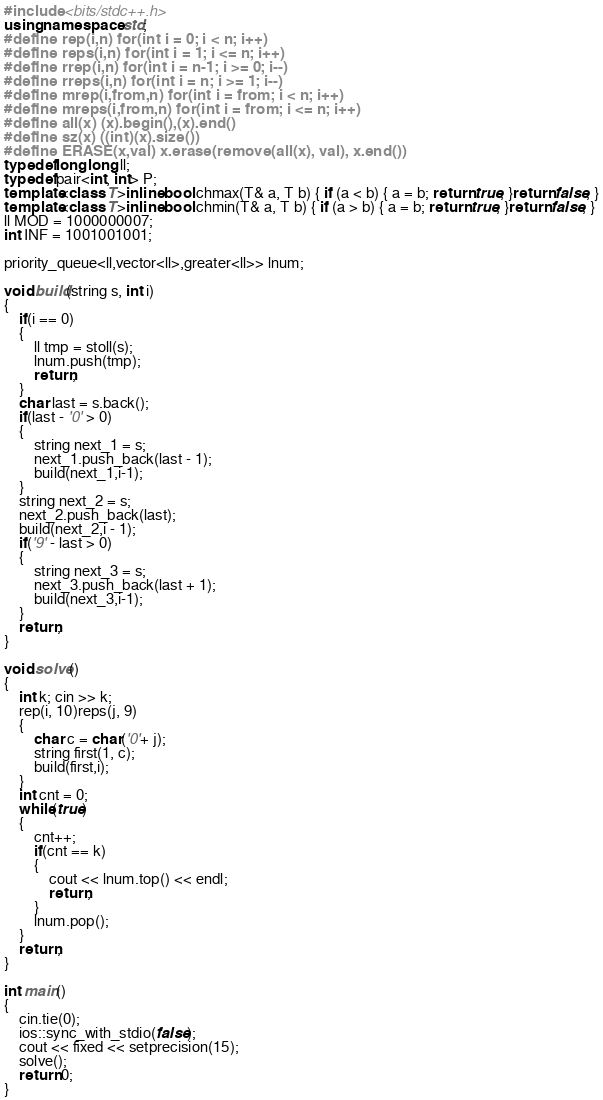Convert code to text. <code><loc_0><loc_0><loc_500><loc_500><_C++_>#include <bits/stdc++.h>
using namespace std;
#define rep(i,n) for(int i = 0; i < n; i++)
#define reps(i,n) for(int i = 1; i <= n; i++)
#define rrep(i,n) for(int i = n-1; i >= 0; i--)
#define rreps(i,n) for(int i = n; i >= 1; i--)
#define mrep(i,from,n) for(int i = from; i < n; i++)
#define mreps(i,from,n) for(int i = from; i <= n; i++)
#define all(x) (x).begin(),(x).end()
#define sz(x) ((int)(x).size())
#define ERASE(x,val) x.erase(remove(all(x), val), x.end())
typedef long long ll;
typedef pair<int, int> P;
template<class T>inline bool chmax(T& a, T b) { if (a < b) { a = b; return true; }return false; }
template<class T>inline bool chmin(T& a, T b) { if (a > b) { a = b; return true; }return false; }
ll MOD = 1000000007;
int INF = 1001001001;

priority_queue<ll,vector<ll>,greater<ll>> lnum;

void build(string s, int i)
{
    if(i == 0)
    {
        ll tmp = stoll(s);
        lnum.push(tmp);
        return;
    }
    char last = s.back();
    if(last - '0' > 0)
    {
        string next_1 = s;
        next_1.push_back(last - 1);
        build(next_1,i-1);
    }  
    string next_2 = s;
    next_2.push_back(last); 
    build(next_2,i - 1);
    if('9' - last > 0)
    {
        string next_3 = s;
        next_3.push_back(last + 1);
        build(next_3,i-1);
    }
    return;
}

void solve()
{
    int k; cin >> k;
    rep(i, 10)reps(j, 9)
    {
        char c = char('0'+ j);
        string first(1, c);
        build(first,i);
    }
    int cnt = 0;
    while(true)
    {
        cnt++;
        if(cnt == k)
        {
            cout << lnum.top() << endl;
            return;
        }
        lnum.pop();
    }
    return;
}

int main()
{
    cin.tie(0);
    ios::sync_with_stdio(false);
    cout << fixed << setprecision(15);
    solve();
    return 0;
}
</code> 